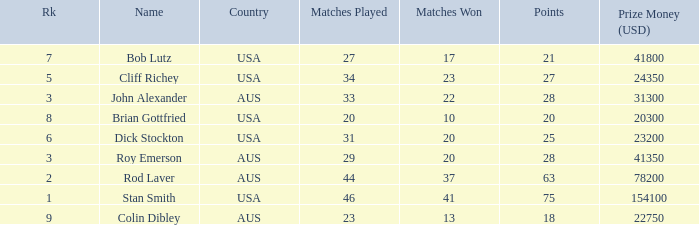How many countries had 21 points 1.0. 